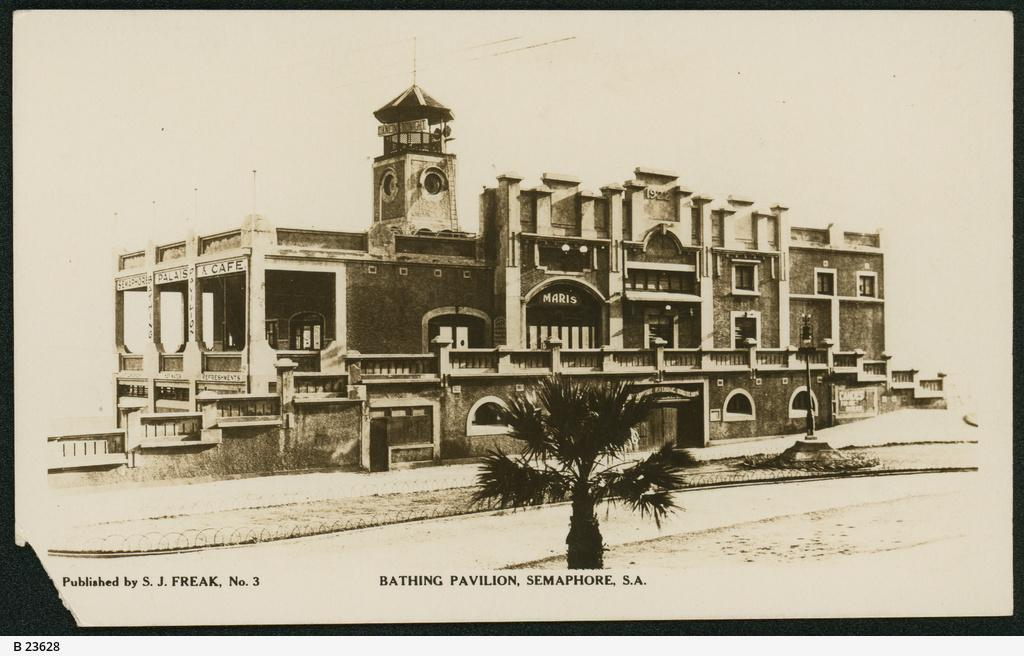What is the color scheme of the image? The image is black and white. What type of structure can be seen in the image? There is a building in the image. What natural element is present in the image? There is a tree in the image. What man-made feature is visible in the image? There is a road in the image. What type of lighting is present in the image? There is a street light in the image. What can be seen in the background of the image? The sky is visible in the background of the image. What is written at the bottom of the image? There is text at the bottom of the image. How many flowers are blooming on the tree in the image? There are no flowers visible on the tree in the image, as it is a black and white image and flowers would not be distinguishable. What type of airplane is flying over the building in the image? There is no airplane present in the image; it only features a building, tree, road, street light, sky, and text. 